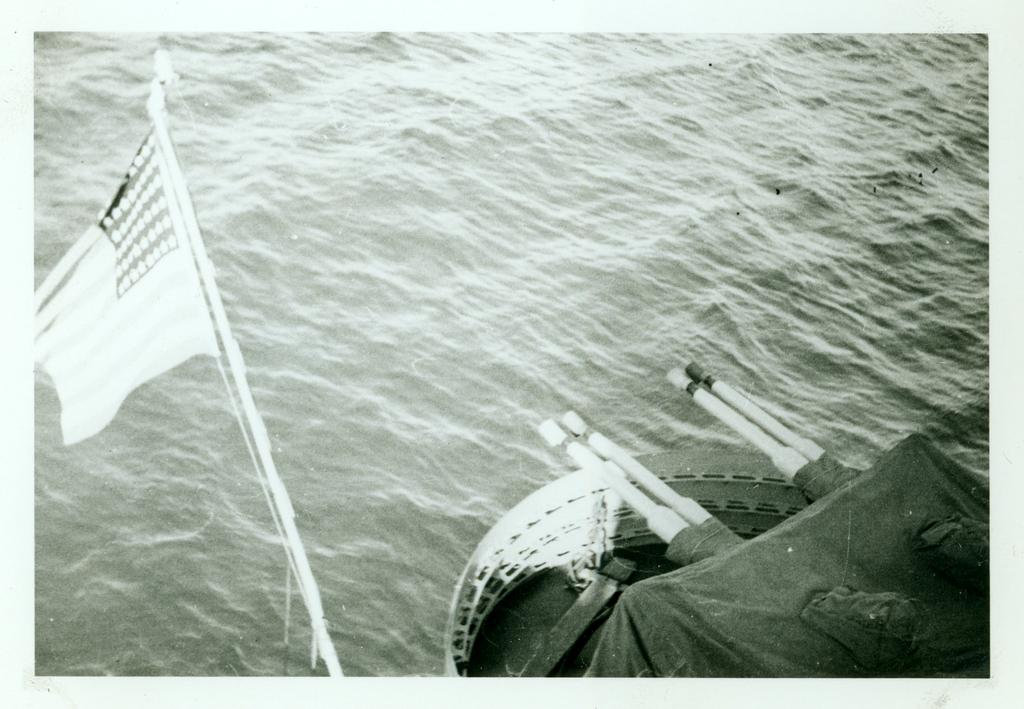What is at the bottom of the image? There is water at the bottom of the image. What can be seen near the water in the image? There is a ship at the right bottom of the image. What is the flag associated with in the image? The flag is visible in the image. What is the color scheme of the image? The image is black and white. Can you describe the frog that is jumping in the water in the image? There is no frog present in the image; it features water, a ship, and a flag. What type of apparatus is being used by the ship in the image? The image does not show any specific apparatus being used by the ship; it only shows the ship itself. 